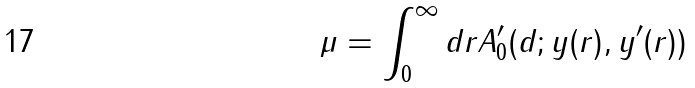Convert formula to latex. <formula><loc_0><loc_0><loc_500><loc_500>\mu = \int _ { 0 } ^ { \infty } d r A ^ { \prime } _ { 0 } ( d ; y ( r ) , y ^ { \prime } ( r ) )</formula> 